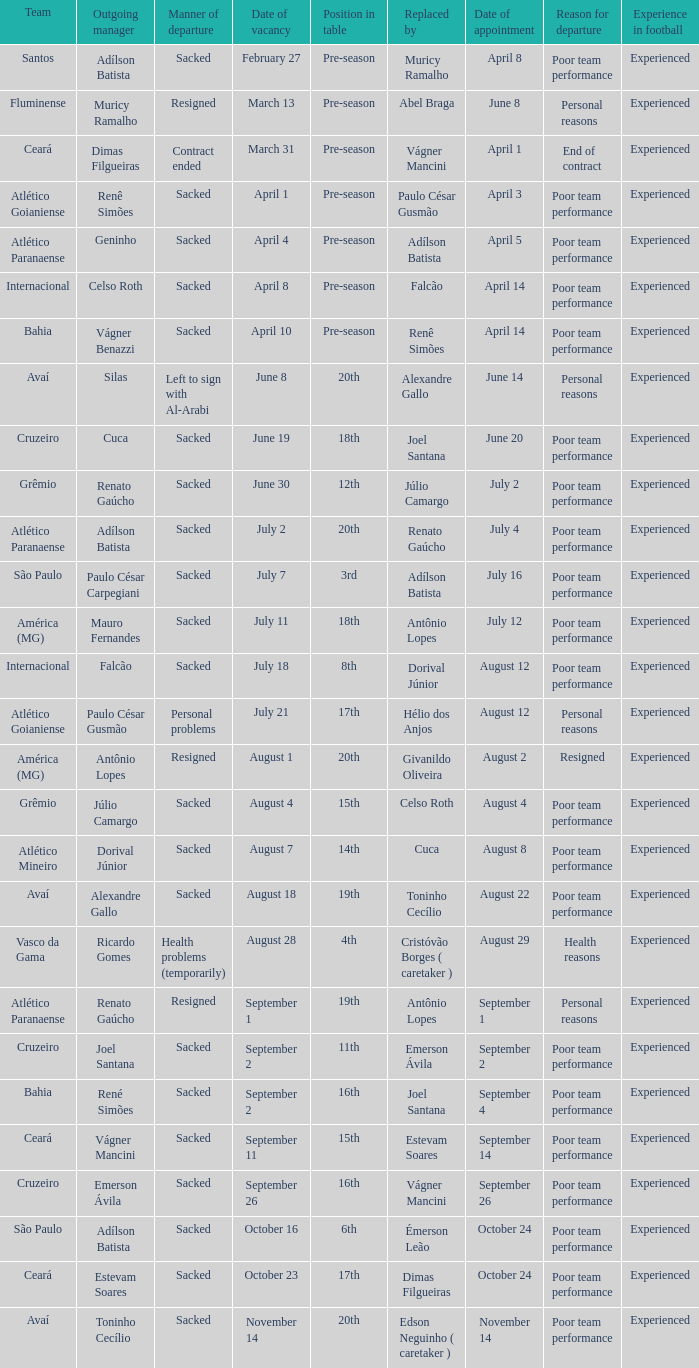Who was the new Santos manager? Muricy Ramalho. 